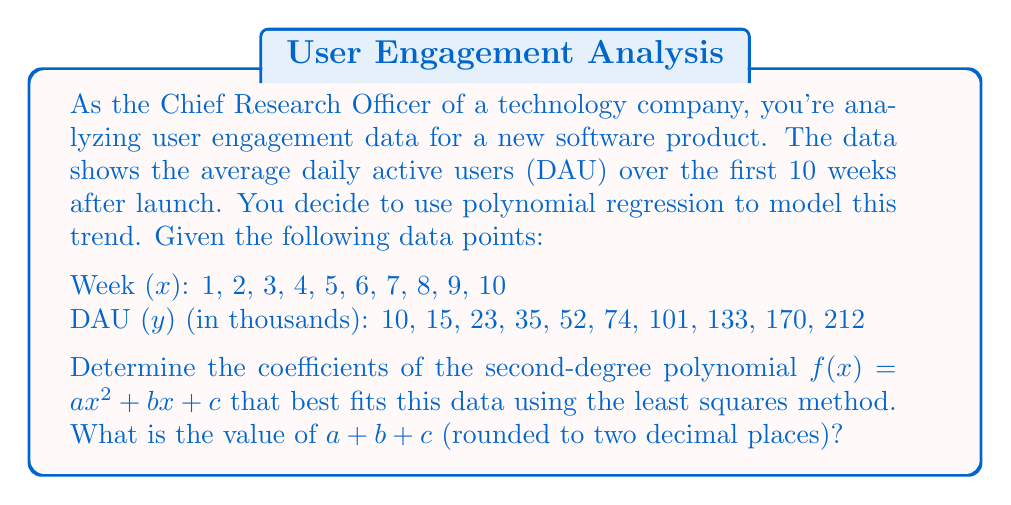Could you help me with this problem? To solve this problem, we'll use the least squares method for polynomial regression. Let's break it down step by step:

1) For a second-degree polynomial $f(x) = ax^2 + bx + c$, we need to solve the following system of normal equations:

   $$\begin{align}
   a\sum x^4 + b\sum x^3 + c\sum x^2 &= \sum x^2y \\
   a\sum x^3 + b\sum x^2 + c\sum x &= \sum xy \\
   a\sum x^2 + b\sum x + cn &= \sum y
   \end{align}$$

   where $n$ is the number of data points (10 in this case).

2) Let's calculate the necessary sums:

   $\sum x = 55$
   $\sum y = 825$
   $\sum x^2 = 385$
   $\sum x^3 = 3025$
   $\sum x^4 = 25333$
   $\sum xy = 6105$
   $\sum x^2y = 49501$

3) Substituting these values into our system of equations:

   $$\begin{align}
   25333a + 3025b + 385c &= 49501 \\
   3025a + 385b + 55c &= 6105 \\
   385a + 55b + 10c &= 825
   \end{align}$$

4) Solving this system of equations (using a method like Gaussian elimination or matrix inversion) gives us:

   $a \approx 2.0655$
   $b \approx -3.3473$
   $c \approx 11.6218$

5) Therefore, our polynomial is approximately:

   $f(x) \approx 2.0655x^2 - 3.3473x + 11.6218$

6) The question asks for $a + b + c$ rounded to two decimal places:

   $2.0655 + (-3.3473) + 11.6218 = 10.3400$
Answer: $a + b + c \approx 10.34$ 